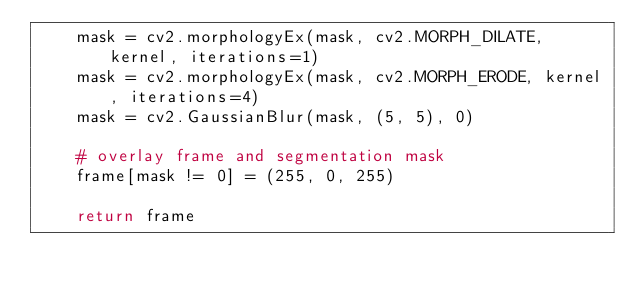<code> <loc_0><loc_0><loc_500><loc_500><_Python_>    mask = cv2.morphologyEx(mask, cv2.MORPH_DILATE, kernel, iterations=1)
    mask = cv2.morphologyEx(mask, cv2.MORPH_ERODE, kernel, iterations=4)
    mask = cv2.GaussianBlur(mask, (5, 5), 0)

    # overlay frame and segmentation mask
    frame[mask != 0] = (255, 0, 255)

    return frame
</code> 